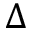<formula> <loc_0><loc_0><loc_500><loc_500>\Delta</formula> 